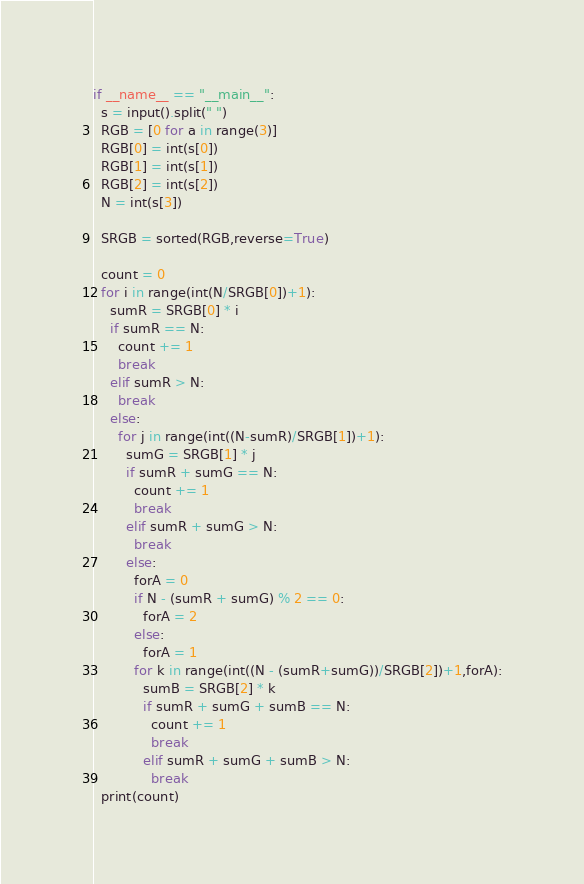Convert code to text. <code><loc_0><loc_0><loc_500><loc_500><_Python_>if __name__ == "__main__":
  s = input().split(" ")
  RGB = [0 for a in range(3)]
  RGB[0] = int(s[0])
  RGB[1] = int(s[1])
  RGB[2] = int(s[2])
  N = int(s[3])
  
  SRGB = sorted(RGB,reverse=True)
  
  count = 0
  for i in range(int(N/SRGB[0])+1):
    sumR = SRGB[0] * i
    if sumR == N:
      count += 1
      break
    elif sumR > N:
      break
    else:
      for j in range(int((N-sumR)/SRGB[1])+1):
        sumG = SRGB[1] * j
        if sumR + sumG == N:
          count += 1
          break
        elif sumR + sumG > N:
          break
        else:
          forA = 0
          if N - (sumR + sumG) % 2 == 0:
            forA = 2
          else:
            forA = 1
          for k in range(int((N - (sumR+sumG))/SRGB[2])+1,forA):
            sumB = SRGB[2] * k
            if sumR + sumG + sumB == N:
              count += 1
              break
            elif sumR + sumG + sumB > N:
              break
  print(count)</code> 